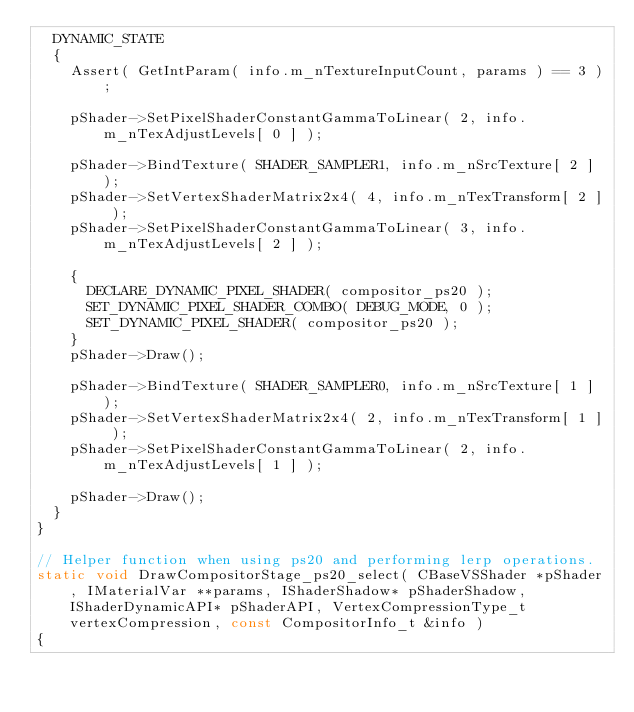<code> <loc_0><loc_0><loc_500><loc_500><_C++_>	DYNAMIC_STATE
	{
		Assert( GetIntParam( info.m_nTextureInputCount, params ) == 3 );

		pShader->SetPixelShaderConstantGammaToLinear( 2, info.m_nTexAdjustLevels[ 0 ] );

		pShader->BindTexture( SHADER_SAMPLER1, info.m_nSrcTexture[ 2 ] );
		pShader->SetVertexShaderMatrix2x4( 4, info.m_nTexTransform[ 2 ] );
		pShader->SetPixelShaderConstantGammaToLinear( 3, info.m_nTexAdjustLevels[ 2 ] );

		{
			DECLARE_DYNAMIC_PIXEL_SHADER( compositor_ps20 );
			SET_DYNAMIC_PIXEL_SHADER_COMBO( DEBUG_MODE, 0 );
			SET_DYNAMIC_PIXEL_SHADER( compositor_ps20 );
		}
		pShader->Draw();

		pShader->BindTexture( SHADER_SAMPLER0, info.m_nSrcTexture[ 1 ] );
		pShader->SetVertexShaderMatrix2x4( 2, info.m_nTexTransform[ 1 ] );
		pShader->SetPixelShaderConstantGammaToLinear( 2, info.m_nTexAdjustLevels[ 1 ] );

		pShader->Draw();
	}
}

// Helper function when using ps20 and performing lerp operations.
static void DrawCompositorStage_ps20_select( CBaseVSShader *pShader, IMaterialVar **params, IShaderShadow* pShaderShadow, IShaderDynamicAPI* pShaderAPI, VertexCompressionType_t vertexCompression, const CompositorInfo_t &info )
{</code> 